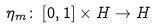<formula> <loc_0><loc_0><loc_500><loc_500>\eta _ { m } \colon \left [ 0 , 1 \right ] \times H \rightarrow H</formula> 